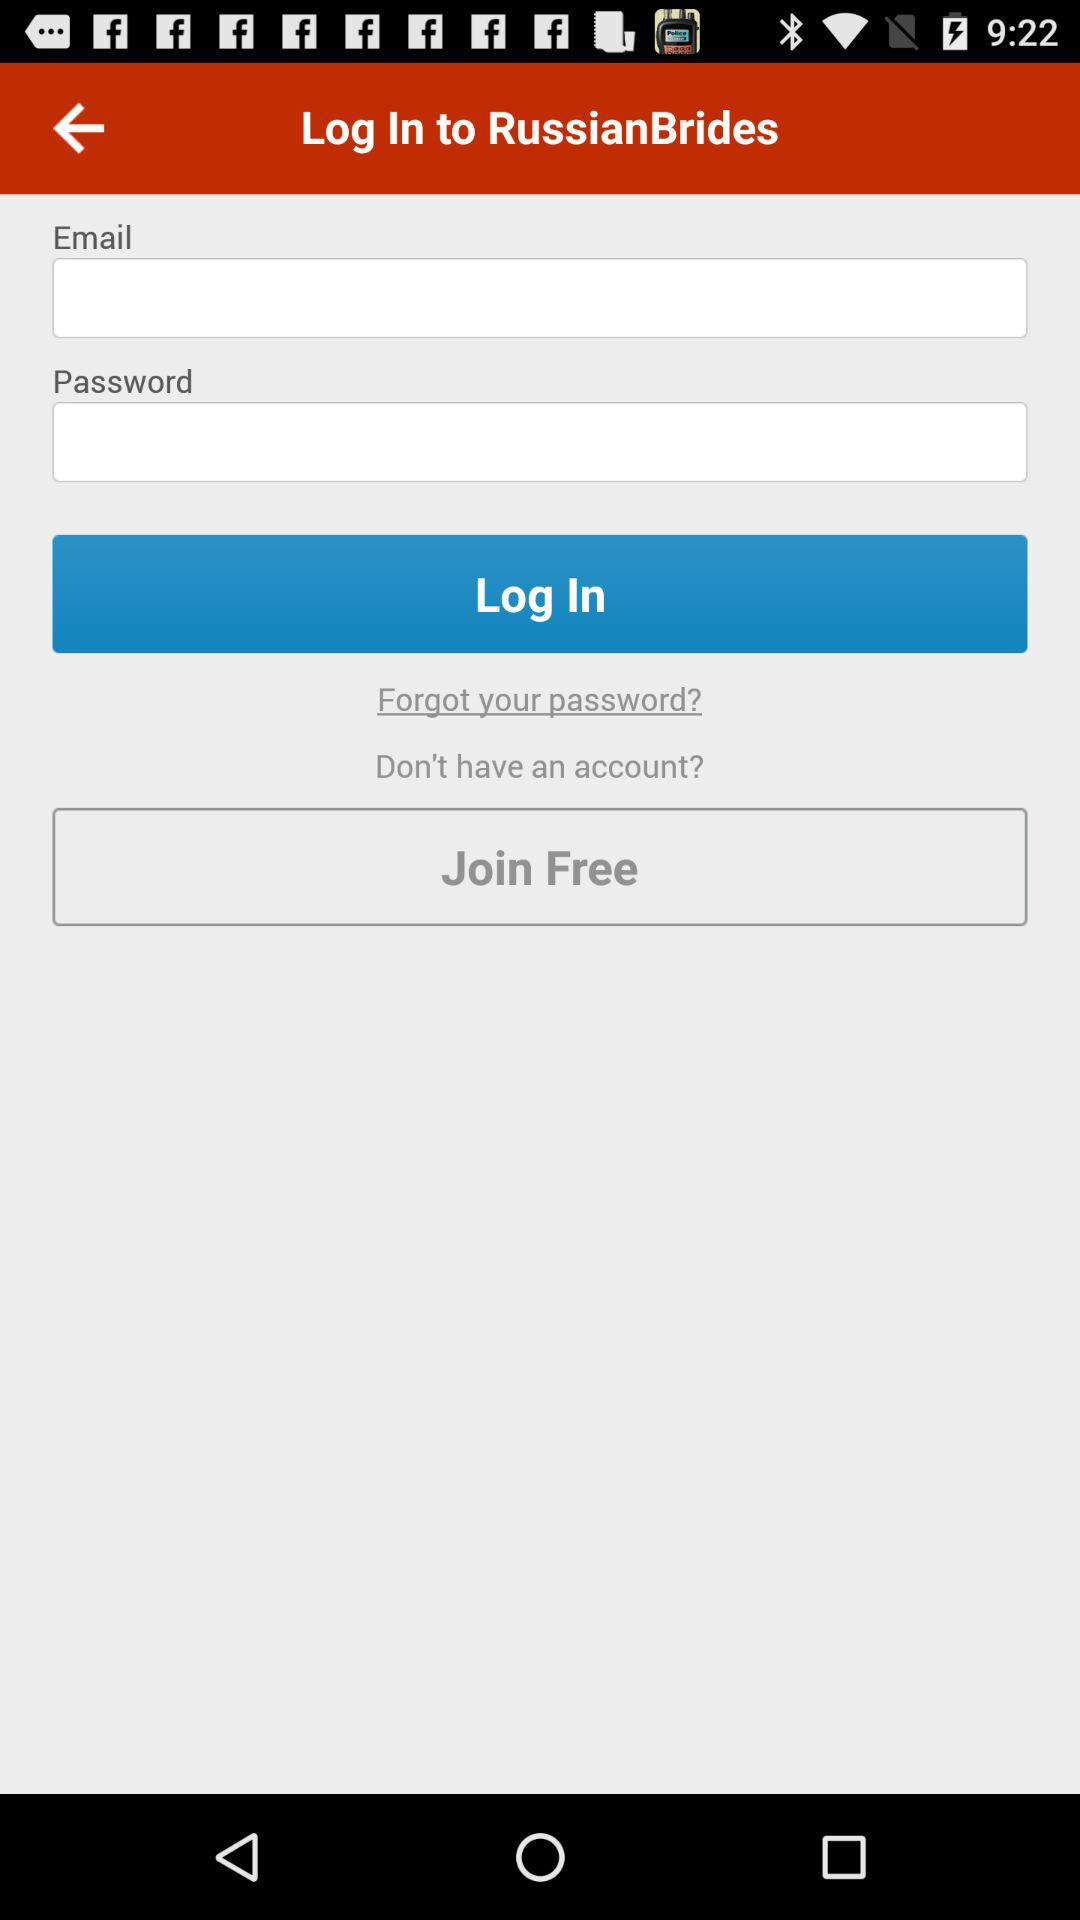How many fields do you need to fill out to log in?
Answer the question using a single word or phrase. 2 